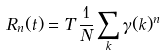<formula> <loc_0><loc_0><loc_500><loc_500>R _ { n } ( t ) = T \, \frac { 1 } { N } \sum _ { k } \gamma ( { k } ) ^ { n }</formula> 